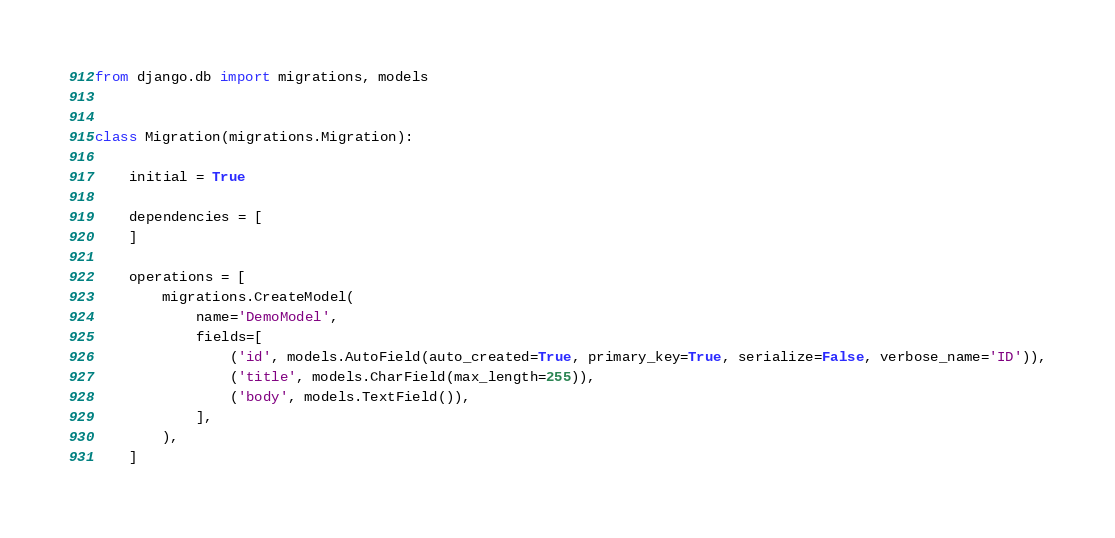Convert code to text. <code><loc_0><loc_0><loc_500><loc_500><_Python_>
from django.db import migrations, models


class Migration(migrations.Migration):

    initial = True

    dependencies = [
    ]

    operations = [
        migrations.CreateModel(
            name='DemoModel',
            fields=[
                ('id', models.AutoField(auto_created=True, primary_key=True, serialize=False, verbose_name='ID')),
                ('title', models.CharField(max_length=255)),
                ('body', models.TextField()),
            ],
        ),
    ]
</code> 